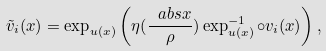Convert formula to latex. <formula><loc_0><loc_0><loc_500><loc_500>\tilde { v } _ { i } ( x ) = \exp _ { u ( x ) } \left ( \eta ( \frac { \ a b s { x } } { \rho } ) \exp ^ { - 1 } _ { u ( x ) } \circ v _ { i } ( x ) \right ) ,</formula> 